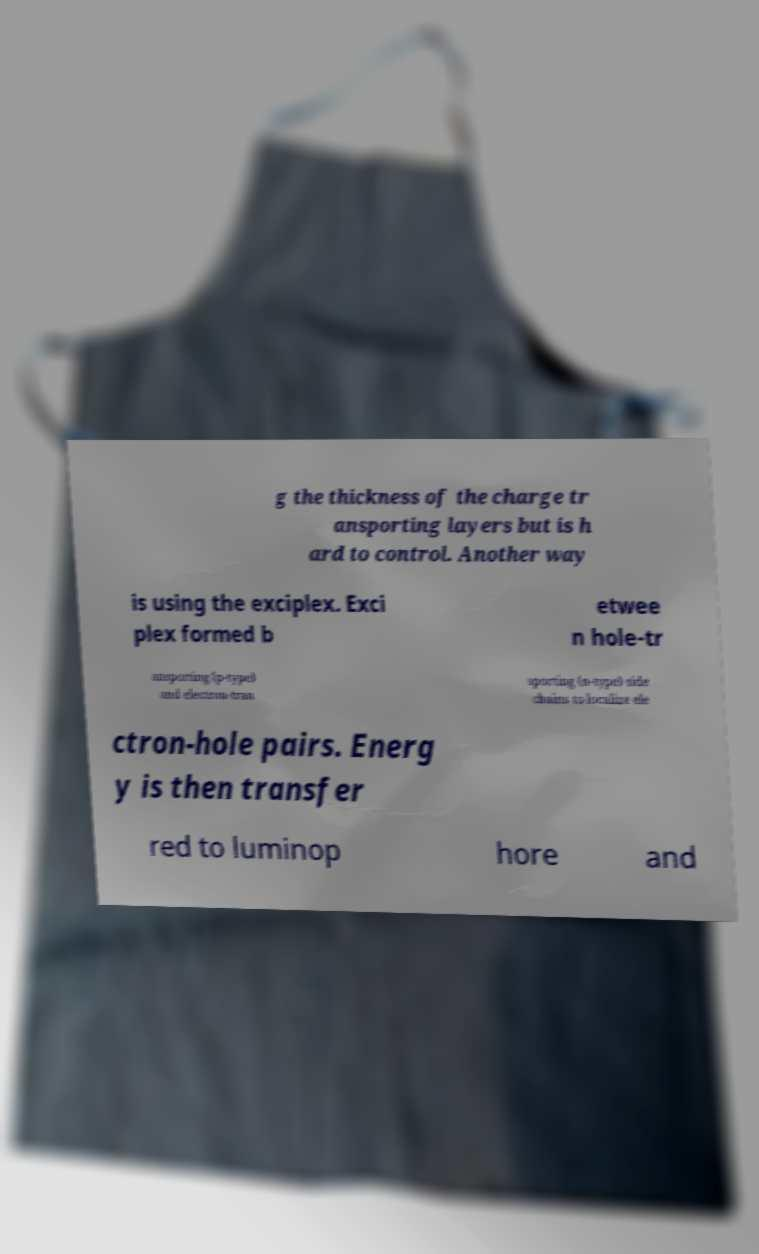Can you read and provide the text displayed in the image?This photo seems to have some interesting text. Can you extract and type it out for me? g the thickness of the charge tr ansporting layers but is h ard to control. Another way is using the exciplex. Exci plex formed b etwee n hole-tr ansporting (p-type) and electron-tran sporting (n-type) side chains to localize ele ctron-hole pairs. Energ y is then transfer red to luminop hore and 